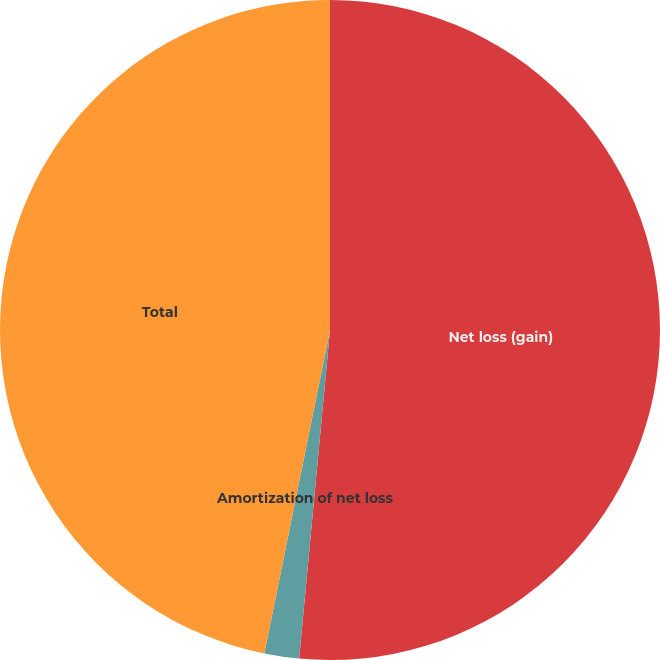Convert chart. <chart><loc_0><loc_0><loc_500><loc_500><pie_chart><fcel>Net loss (gain)<fcel>Amortization of net loss<fcel>Total<nl><fcel>51.49%<fcel>1.7%<fcel>46.81%<nl></chart> 